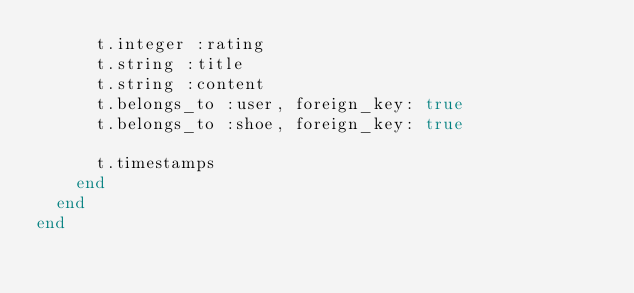Convert code to text. <code><loc_0><loc_0><loc_500><loc_500><_Ruby_>      t.integer :rating
      t.string :title
      t.string :content
      t.belongs_to :user, foreign_key: true
      t.belongs_to :shoe, foreign_key: true

      t.timestamps
    end
  end
end
</code> 